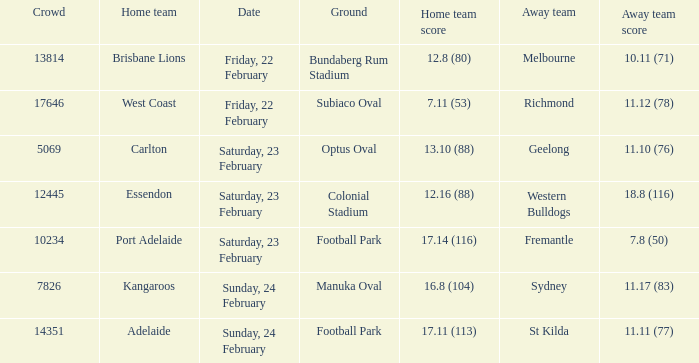On what date did the away team Fremantle play? Saturday, 23 February. 